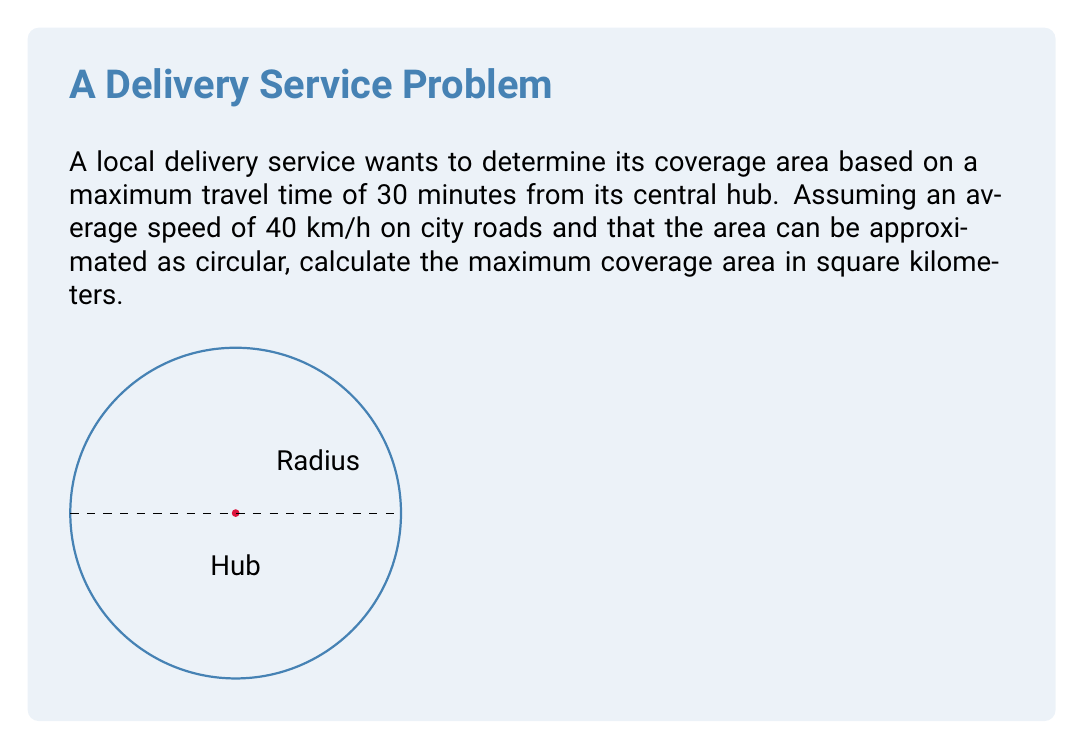Give your solution to this math problem. 1. Calculate the maximum distance that can be traveled in 30 minutes:
   Time = 30 minutes = 0.5 hours
   Speed = 40 km/h
   Distance = Speed × Time
   $$ d = 40 \text{ km/h} \times 0.5 \text{ h} = 20 \text{ km} $$

2. This distance represents the radius of the circular coverage area.

3. Use the formula for the area of a circle: $A = \pi r^2$
   where $r$ is the radius (20 km)

4. Calculate the area:
   $$ A = \pi \times (20 \text{ km})^2 $$
   $$ A = \pi \times 400 \text{ km}^2 $$
   $$ A \approx 1256.64 \text{ km}^2 $$

5. Round to two decimal places for practical use.
Answer: 1256.64 km² 